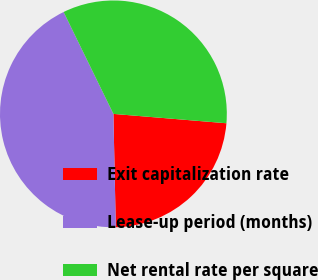Convert chart. <chart><loc_0><loc_0><loc_500><loc_500><pie_chart><fcel>Exit capitalization rate<fcel>Lease-up period (months)<fcel>Net rental rate per square<nl><fcel>23.35%<fcel>43.1%<fcel>33.55%<nl></chart> 